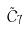<formula> <loc_0><loc_0><loc_500><loc_500>\tilde { C } _ { 7 }</formula> 